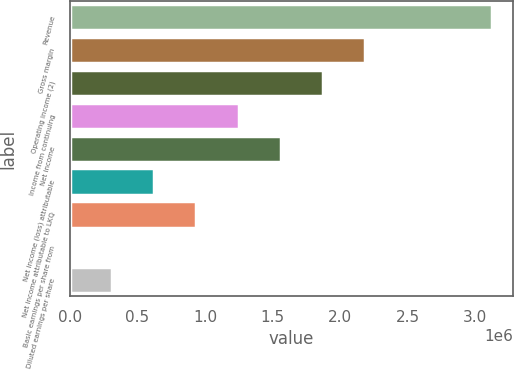Convert chart. <chart><loc_0><loc_0><loc_500><loc_500><bar_chart><fcel>Revenue<fcel>Gross margin<fcel>Operating income (2)<fcel>Income from continuing<fcel>Net income<fcel>Net income (loss) attributable<fcel>Net income attributable to LKQ<fcel>Basic earnings per share from<fcel>Diluted earnings per share<nl><fcel>3.12238e+06<fcel>2.18566e+06<fcel>1.87343e+06<fcel>1.24895e+06<fcel>1.56119e+06<fcel>624476<fcel>936714<fcel>0.42<fcel>312238<nl></chart> 